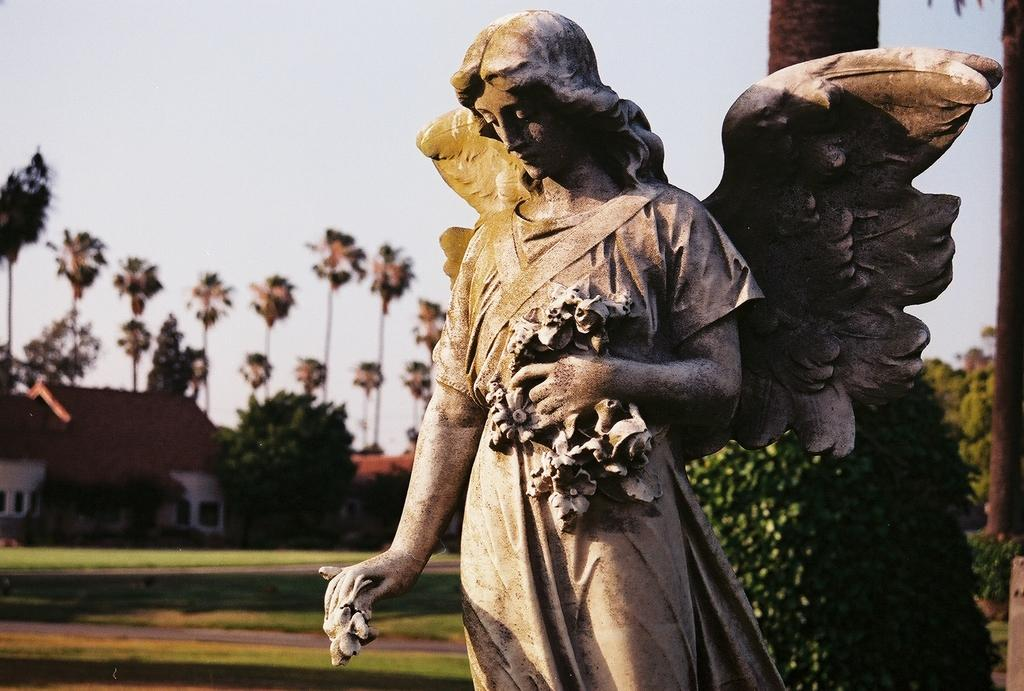What is the main subject of the image? There is a sculpture of a woman in the image. What is the sculpture wearing? The sculpture is wearing clothes. What other objects or elements can be seen in the image? There are feathers, trees, a house, grass, and the sky visible in the image. What type of plough can be seen in the image? There is no plough present in the image. How many railway tracks are visible in the image? There are no railway tracks visible in the image. 